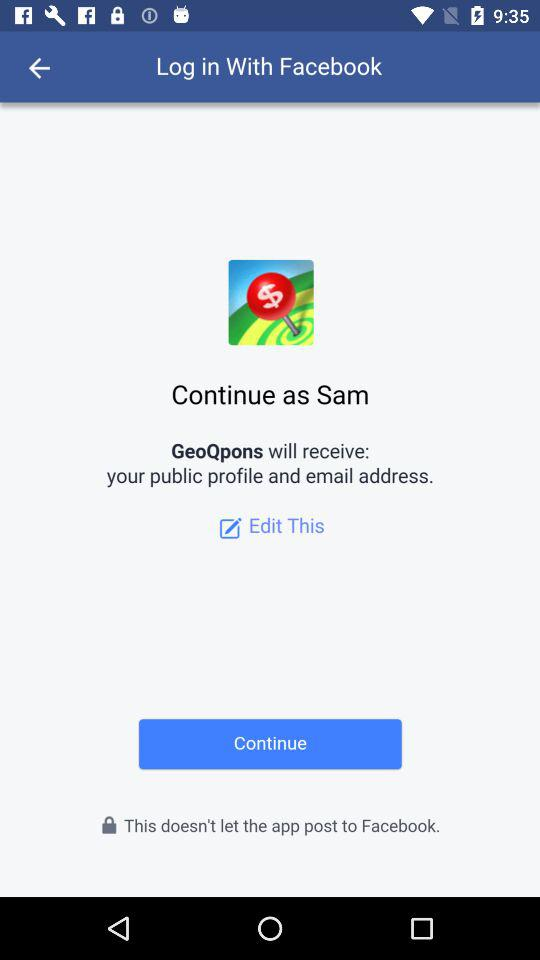What application will receive the public profile and email address? The public profile and email address will be received by "GeoQpons". 